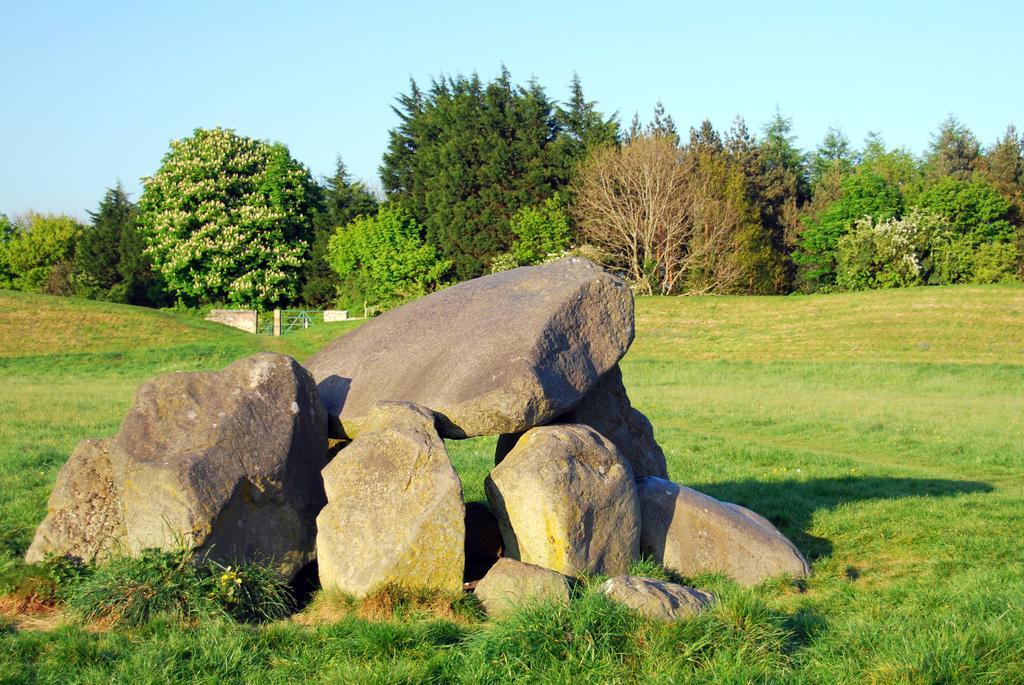Could you give a brief overview of what you see in this image? In this image I can see the ground, some grass on the ground and few huge rocks. In the background I can see few trees which are green in color, few flowers which are white in color and the sky. 